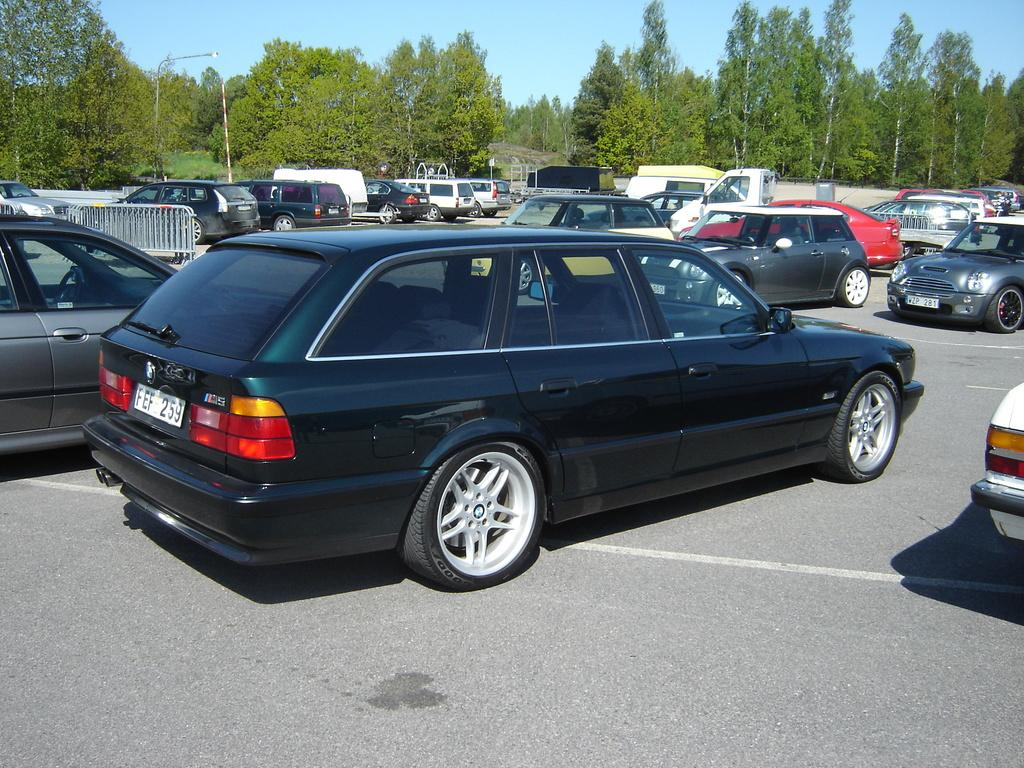What can be seen on the road in the image? There are cars on the road in the image. What type of natural scenery is visible in the background? There are trees in the background of the image. What structures can be seen in the image? There are poles visible in the image. What part of the natural environment is visible in the image? The sky is visible in the image. Can you see a bear eating breakfast while running in the image? There is no bear or any breakfast scene in the image; it features cars on the road, trees in the background, poles, and the sky. 